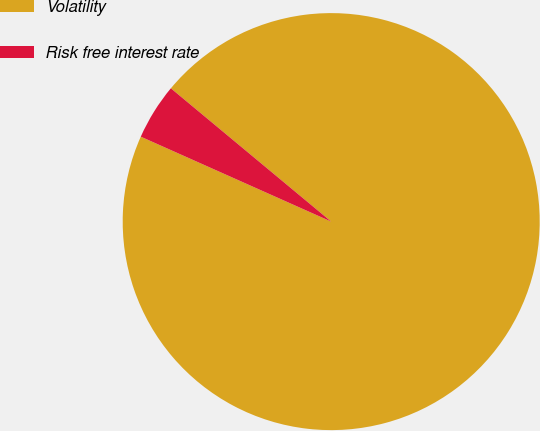Convert chart to OTSL. <chart><loc_0><loc_0><loc_500><loc_500><pie_chart><fcel>Volatility<fcel>Risk free interest rate<nl><fcel>95.64%<fcel>4.36%<nl></chart> 